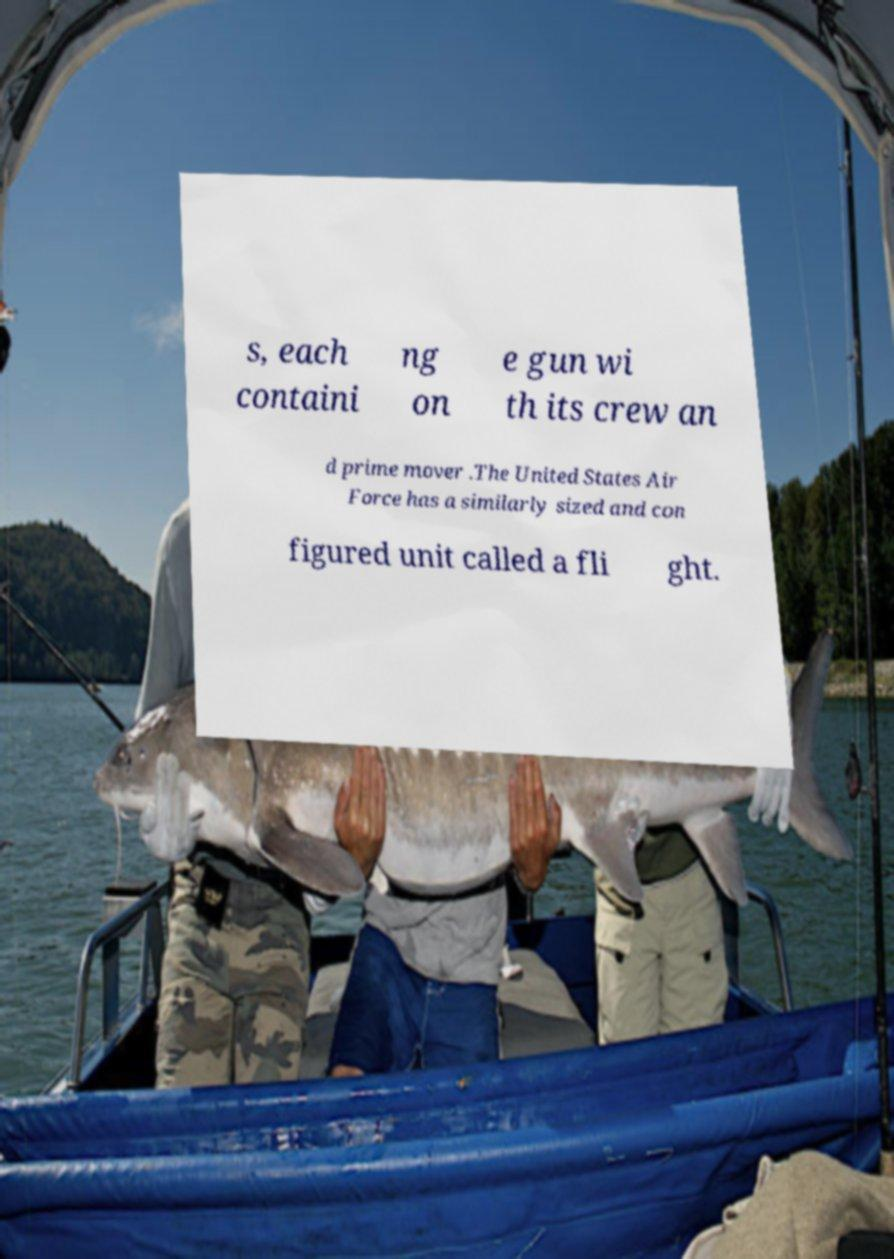I need the written content from this picture converted into text. Can you do that? s, each containi ng on e gun wi th its crew an d prime mover .The United States Air Force has a similarly sized and con figured unit called a fli ght. 